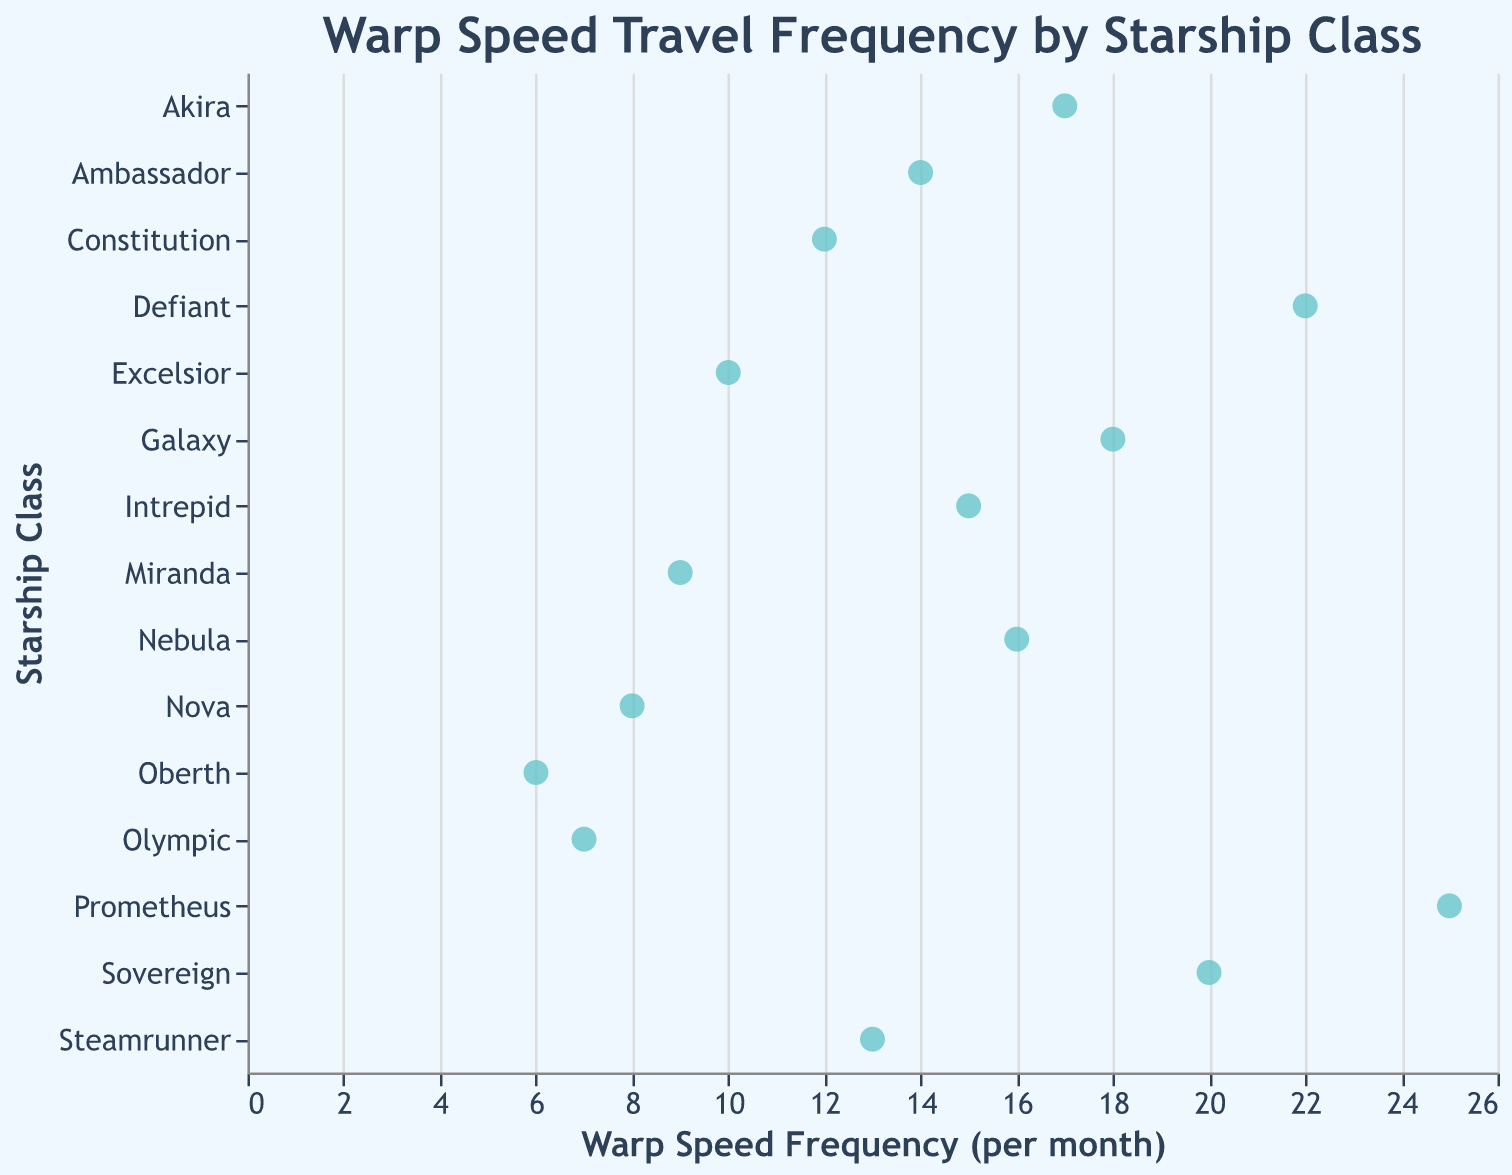What's the title of the figure? The title appears at the top of the plot and reads "Warp Speed Travel Frequency by Starship Class".
Answer: Warp Speed Travel Frequency by Starship Class How many starship classes are represented in the figure? The y-axis lists each starship class, and there are 15 points plotted, each representing a different starship class.
Answer: 15 Which starship class has the highest warp speed frequency per month? By looking at the highest point along the x-axis, we see that "Prometheus" has the highest value at 25.
Answer: Prometheus Which starship classes have a warp speed frequency less than 10 per month? The data points that lie to the left of 10 on the x-axis correspond to the following starship classes: Oberth, Olympic, Nova, and Miranda.
Answer: Oberth, Olympic, Nova, Miranda What is the median warp speed frequency per month among the starship classes? Listing the frequencies in order: 6, 7, 8, 9, 10, 12, 13, 14, 15, 16, 17, 18, 20, 22, 25, then the middle value in this ordered list is 14.
Answer: 14 Which starship class has a warp speed frequency closest to the median frequency? The median value is 14, and "Ambassador" has a warp speed frequency of 14, which matches the median.
Answer: Ambassador How does the warp speed frequency of the "Defiant" class compare to the "Constitution" class? The warp speed frequency for "Defiant" is 22, while for "Constitution" it is 12; therefore, the "Defiant" has a higher frequency by 10.
Answer: Defiant is higher by 10 What is the average warp speed frequency per month among all starship classes? Sum all the frequencies and divide by the number of starship classes: (12 + 18 + 15 + 22 + 20 + 10 + 14 + 16 + 8 + 25 + 9 + 17 + 6 + 13 + 7) / 15 = 212 / 15 = 14.13.
Answer: 14.13 Which two starship classes have the closest warp speed frequencies? Comparing the differences, "Galaxy" (18) and "Akira" (17) have the smallest difference of 1.
Answer: Galaxy and Akira 